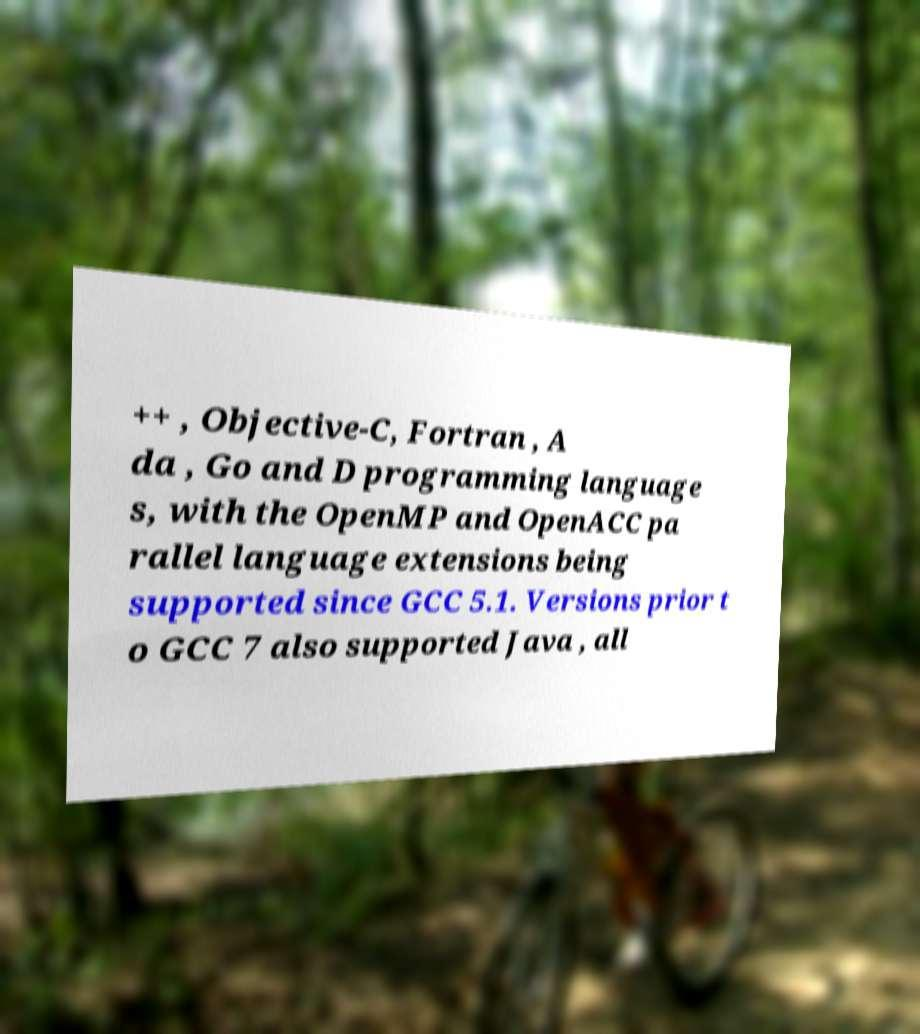Can you accurately transcribe the text from the provided image for me? ++ , Objective-C, Fortran , A da , Go and D programming language s, with the OpenMP and OpenACC pa rallel language extensions being supported since GCC 5.1. Versions prior t o GCC 7 also supported Java , all 